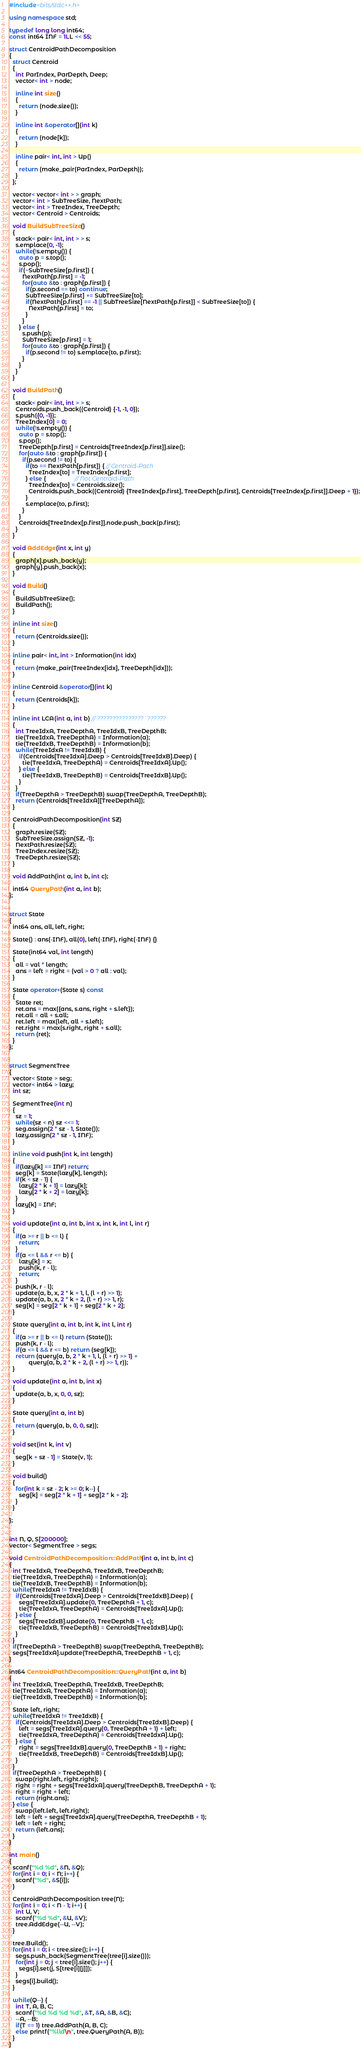<code> <loc_0><loc_0><loc_500><loc_500><_C++_>#include<bits/stdc++.h>
 
using namespace std;
 
typedef long long int64;
const int64 INF = 1LL << 55;
 
struct CentroidPathDecomposition
{
  struct Centroid
  {
    int ParIndex, ParDepth, Deep;
    vector< int > node;
 
    inline int size()
    {
      return (node.size());
    }
 
    inline int &operator[](int k)
    {
      return (node[k]);
    }
 
    inline pair< int, int > Up()
    {
      return (make_pair(ParIndex, ParDepth));
    }
  };
 
  vector< vector< int > > graph;
  vector< int > SubTreeSize, NextPath;
  vector< int > TreeIndex, TreeDepth;
  vector< Centroid > Centroids;
 
  void BuildSubTreeSize()
  {
    stack< pair< int, int > > s;
    s.emplace(0, -1);
    while(!s.empty()) {
      auto p = s.top();
      s.pop();
      if(~SubTreeSize[p.first]) {
        NextPath[p.first] = -1;
        for(auto &to : graph[p.first]) {
          if(p.second == to) continue;
          SubTreeSize[p.first] += SubTreeSize[to];
          if(NextPath[p.first] == -1 || SubTreeSize[NextPath[p.first]] < SubTreeSize[to]) {
            NextPath[p.first] = to;
          }
        }
      } else {
        s.push(p);
        SubTreeSize[p.first] = 1;
        for(auto &to : graph[p.first]) {
          if(p.second != to) s.emplace(to, p.first);
        }
      }
    }
  }
 
  void BuildPath()
  {
    stack< pair< int, int > > s;
    Centroids.push_back((Centroid) {-1, -1, 0});
    s.push({0, -1});
    TreeIndex[0] = 0;
    while(!s.empty()) {
      auto p = s.top();
      s.pop();
      TreeDepth[p.first] = Centroids[TreeIndex[p.first]].size();
      for(auto &to : graph[p.first]) {
        if(p.second != to) {
          if(to == NextPath[p.first]) { // Centroid-Path
            TreeIndex[to] = TreeIndex[p.first];
          } else {                  // Not Centroid-Path
            TreeIndex[to] = Centroids.size();
            Centroids.push_back((Centroid) {TreeIndex[p.first], TreeDepth[p.first], Centroids[TreeIndex[p.first]].Deep + 1});
          }
          s.emplace(to, p.first);
        }
      }
      Centroids[TreeIndex[p.first]].node.push_back(p.first);
    }
  }
 
  void AddEdge(int x, int y)
  {
    graph[x].push_back(y);
    graph[y].push_back(x);
  }
 
  void Build()
  {
    BuildSubTreeSize();
    BuildPath();
  }
 
  inline int size()
  {
    return (Centroids.size());
  }
 
  inline pair< int, int > Information(int idx)
  {
    return (make_pair(TreeIndex[idx], TreeDepth[idx]));
  }
 
  inline Centroid &operator[](int k)
  {
    return (Centroids[k]);
  }
 
  inline int LCA(int a, int b) // ???????????????¨??????
  {
    int TreeIdxA, TreeDepthA, TreeIdxB, TreeDepthB;
    tie(TreeIdxA, TreeDepthA) = Information(a);
    tie(TreeIdxB, TreeDepthB) = Information(b);
    while(TreeIdxA != TreeIdxB) {
      if(Centroids[TreeIdxA].Deep > Centroids[TreeIdxB].Deep) {
        tie(TreeIdxA, TreeDepthA) = Centroids[TreeIdxA].Up();
      } else {
        tie(TreeIdxB, TreeDepthB) = Centroids[TreeIdxB].Up();
      }
    }
    if(TreeDepthA > TreeDepthB) swap(TreeDepthA, TreeDepthB);
    return (Centroids[TreeIdxA][TreeDepthA]);
  }
 
  CentroidPathDecomposition(int SZ)
  {
    graph.resize(SZ);
    SubTreeSize.assign(SZ, -1);
    NextPath.resize(SZ);
    TreeIndex.resize(SZ);
    TreeDepth.resize(SZ);
  }
 
  void AddPath(int a, int b, int c);
 
  int64 QueryPath(int a, int b);
};
 
 
struct State
{
  int64 ans, all, left, right;
 
  State() : ans(-INF), all(0), left(-INF), right(-INF) {}
 
  State(int64 val, int length)
  {
    all = val * length;
    ans = left = right = (val > 0 ? all : val);
  }
 
  State operator+(State s) const
  {
    State ret;
    ret.ans = max({ans, s.ans, right + s.left});
    ret.all = all + s.all;
    ret.left = max(left, all + s.left);
    ret.right = max(s.right, right + s.all);
    return (ret);
  }
};
 
 
struct SegmentTree
{
  vector< State > seg;
  vector< int64 > lazy;
  int sz;
 
  SegmentTree(int n)
  {
    sz = 1;
    while(sz < n) sz <<= 1;
    seg.assign(2 * sz - 1, State());
    lazy.assign(2 * sz - 1, INF);
  }
 
  inline void push(int k, int length)
  {
    if(lazy[k] == INF) return;
    seg[k] = State(lazy[k], length);
    if(k < sz - 1) {
      lazy[2 * k + 1] = lazy[k];
      lazy[2 * k + 2] = lazy[k];
    }
    lazy[k] = INF;
  }
 
  void update(int a, int b, int x, int k, int l, int r)
  {
    if(a >= r || b <= l) {
      return;
    }
    if(a <= l && r <= b) {
      lazy[k] = x;
      push(k, r - l);
      return;
    }
    push(k, r - l);
    update(a, b, x, 2 * k + 1, l, (l + r) >> 1);
    update(a, b, x, 2 * k + 2, (l + r) >> 1, r);
    seg[k] = seg[2 * k + 1] + seg[2 * k + 2];
  }
 
  State query(int a, int b, int k, int l, int r)
  {
    if(a >= r || b <= l) return (State());
    push(k, r - l);
    if(a <= l && r <= b) return (seg[k]);
    return (query(a, b, 2 * k + 1, l, (l + r) >> 1) +
            query(a, b, 2 * k + 2, (l + r) >> 1, r));
  }
 
  void update(int a, int b, int x)
  {
    update(a, b, x, 0, 0, sz);
  }
 
  State query(int a, int b)
  {
    return (query(a, b, 0, 0, sz));
  }
 
  void set(int k, int v)
  {
    seg[k + sz - 1] = State(v, 1);
  }
 
  void build()
  {
    for(int k = sz - 2; k >= 0; k--) {
      seg[k] = seg[2 * k + 1] + seg[2 * k + 2];
    }
  }
 
};
 
 
int N, Q, S[200000];
vector< SegmentTree > segs;
 
void CentroidPathDecomposition::AddPath(int a, int b, int c)
{
  int TreeIdxA, TreeDepthA, TreeIdxB, TreeDepthB;
  tie(TreeIdxA, TreeDepthA) = Information(a);
  tie(TreeIdxB, TreeDepthB) = Information(b);
  while(TreeIdxA != TreeIdxB) {
    if(Centroids[TreeIdxA].Deep > Centroids[TreeIdxB].Deep) {
      segs[TreeIdxA].update(0, TreeDepthA + 1, c);
      tie(TreeIdxA, TreeDepthA) = Centroids[TreeIdxA].Up();
    } else {
      segs[TreeIdxB].update(0, TreeDepthB + 1, c);
      tie(TreeIdxB, TreeDepthB) = Centroids[TreeIdxB].Up();
    }
  }
  if(TreeDepthA > TreeDepthB) swap(TreeDepthA, TreeDepthB);
  segs[TreeIdxA].update(TreeDepthA, TreeDepthB + 1, c);
}
 
int64 CentroidPathDecomposition::QueryPath(int a, int b)
{
  int TreeIdxA, TreeDepthA, TreeIdxB, TreeDepthB;
  tie(TreeIdxA, TreeDepthA) = Information(a);
  tie(TreeIdxB, TreeDepthB) = Information(b);
 
  State left, right;
  while(TreeIdxA != TreeIdxB) {
    if(Centroids[TreeIdxA].Deep > Centroids[TreeIdxB].Deep) {
      left = segs[TreeIdxA].query(0, TreeDepthA + 1) + left;
      tie(TreeIdxA, TreeDepthA) = Centroids[TreeIdxA].Up();
    } else {
      right = segs[TreeIdxB].query(0, TreeDepthB + 1) + right;
      tie(TreeIdxB, TreeDepthB) = Centroids[TreeIdxB].Up();
    }
  }
  if(TreeDepthA > TreeDepthB) {
    swap(right.left, right.right);
    right = right + segs[TreeIdxA].query(TreeDepthB, TreeDepthA + 1);
    right = right + left;
    return (right.ans);
  } else {
    swap(left.left, left.right);
    left = left + segs[TreeIdxA].query(TreeDepthA, TreeDepthB + 1);
    left = left + right;
    return (left.ans);
  }
}
 
int main()
{
  scanf("%d %d", &N, &Q);
  for(int i = 0; i < N; i++) {
    scanf("%d", &S[i]);
  }
 
  CentroidPathDecomposition tree(N);
  for(int i = 0; i < N - 1; i++) {
    int U, V;
    scanf("%d %d", &U, &V);
    tree.AddEdge(--U, --V);
  }
 
  tree.Build();
  for(int i = 0; i < tree.size(); i++) {
    segs.push_back(SegmentTree(tree[i].size()));
    for(int j = 0; j < tree[i].size(); j++) {
      segs[i].set(j, S[tree[i][j]]);
    }
    segs[i].build();
  }
 
  while(Q--) {
    int T, A, B, C;
    scanf("%d %d %d %d", &T, &A, &B, &C);
    --A, --B;
    if(T == 1) tree.AddPath(A, B, C);
    else printf("%lld\n", tree.QueryPath(A, B));
  }
}</code> 